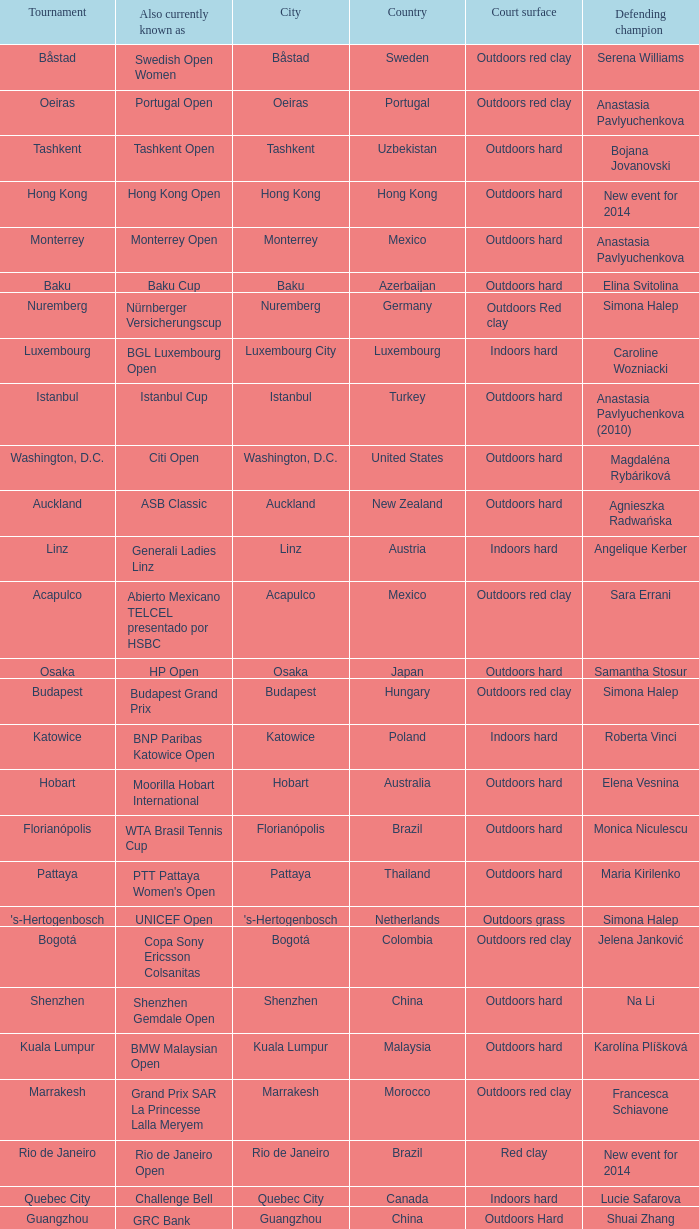What tournament is in katowice? Katowice. 